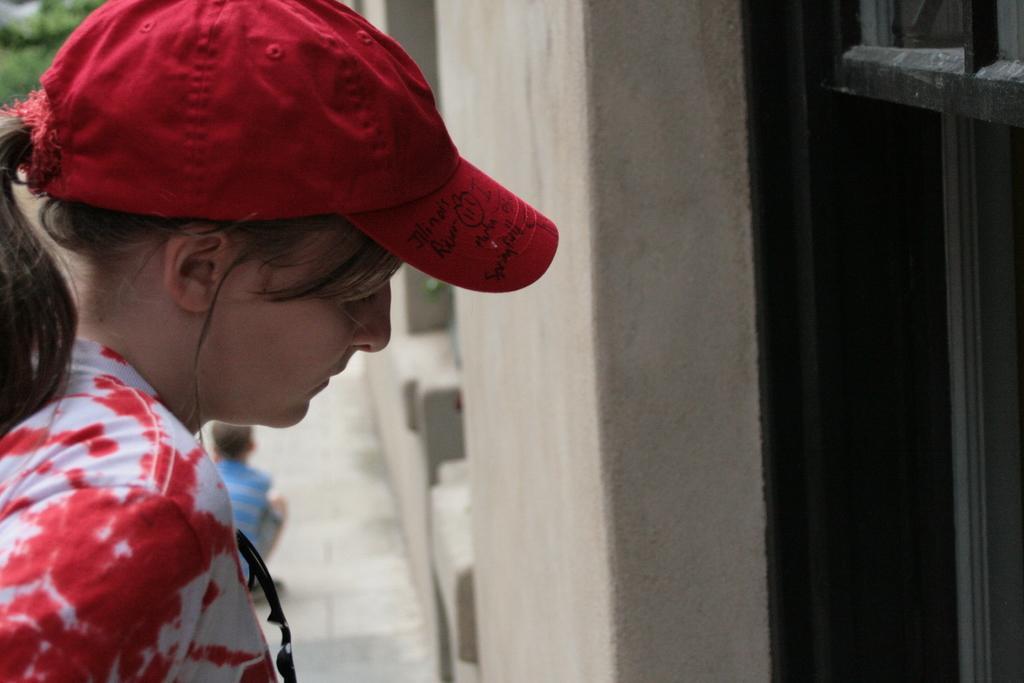Describe this image in one or two sentences. In the image I can see a person who is wearing the cap and standing in front of the door. 